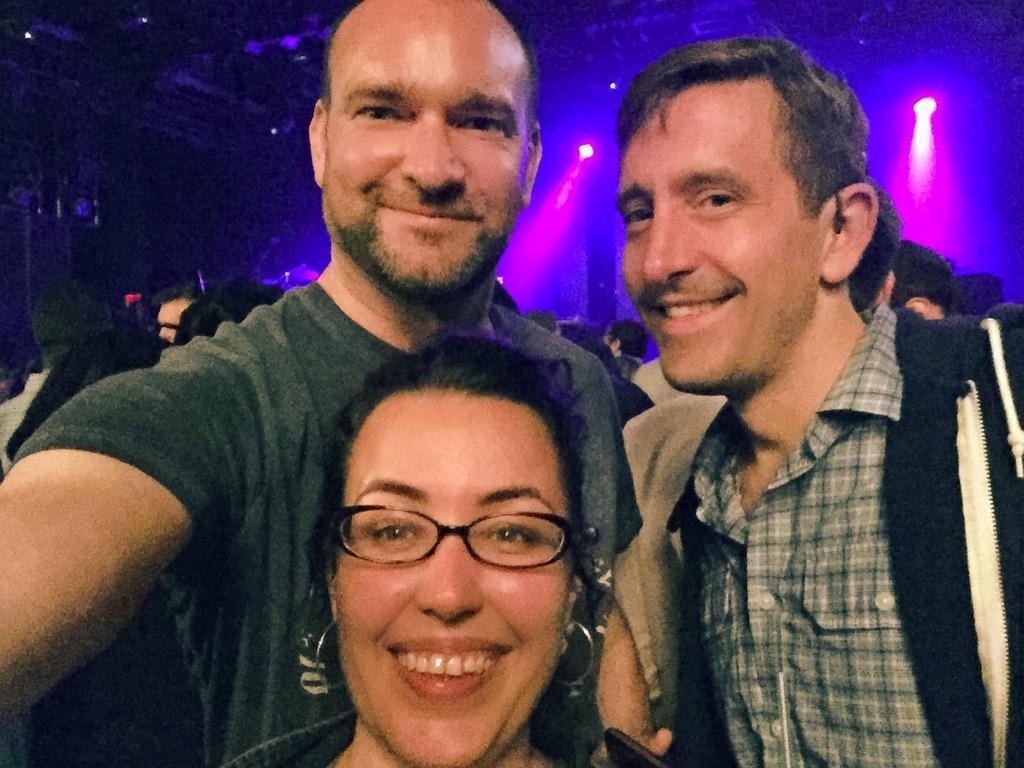Describe this image in one or two sentences. In this image, we can see a few people. We see some lights. We can see a shed on the top. We can see some objects on the left. 